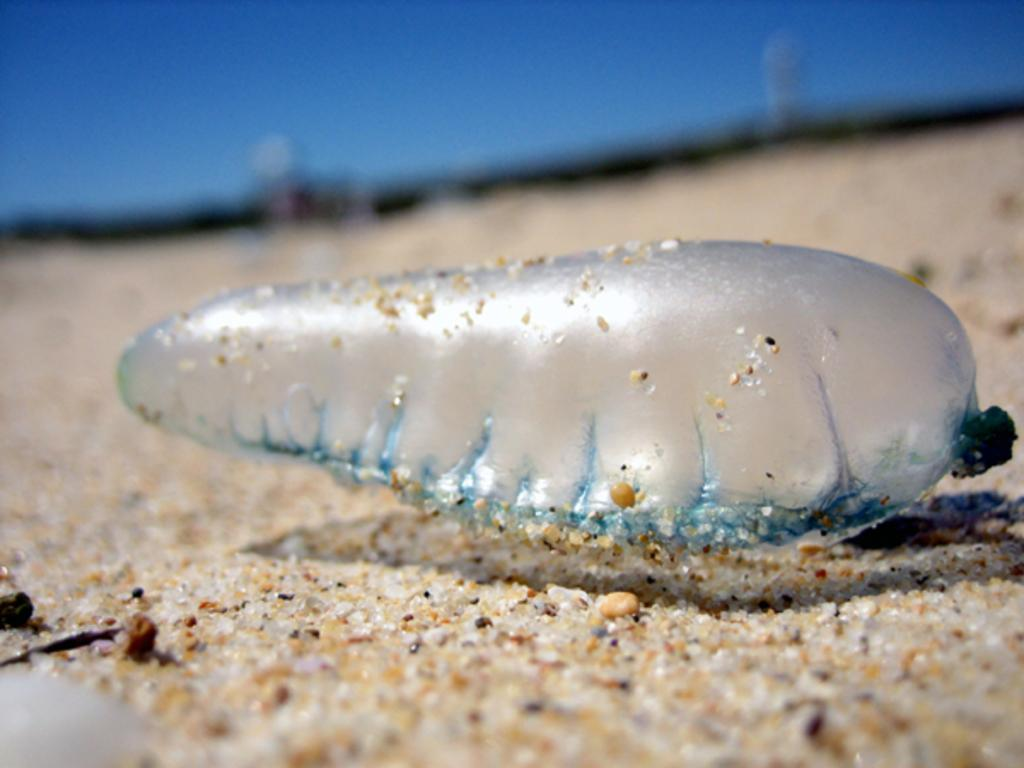What is the shape of the object in the image? The object is oval-shaped in the image. Can you describe the appearance of the object? The object is transparent in the image. What is the object placed on in the image? The object is placed on a sandy surface in the image. What type of fear can be seen in the object in the image? There is no fear present in the image, as it is an inanimate object. 